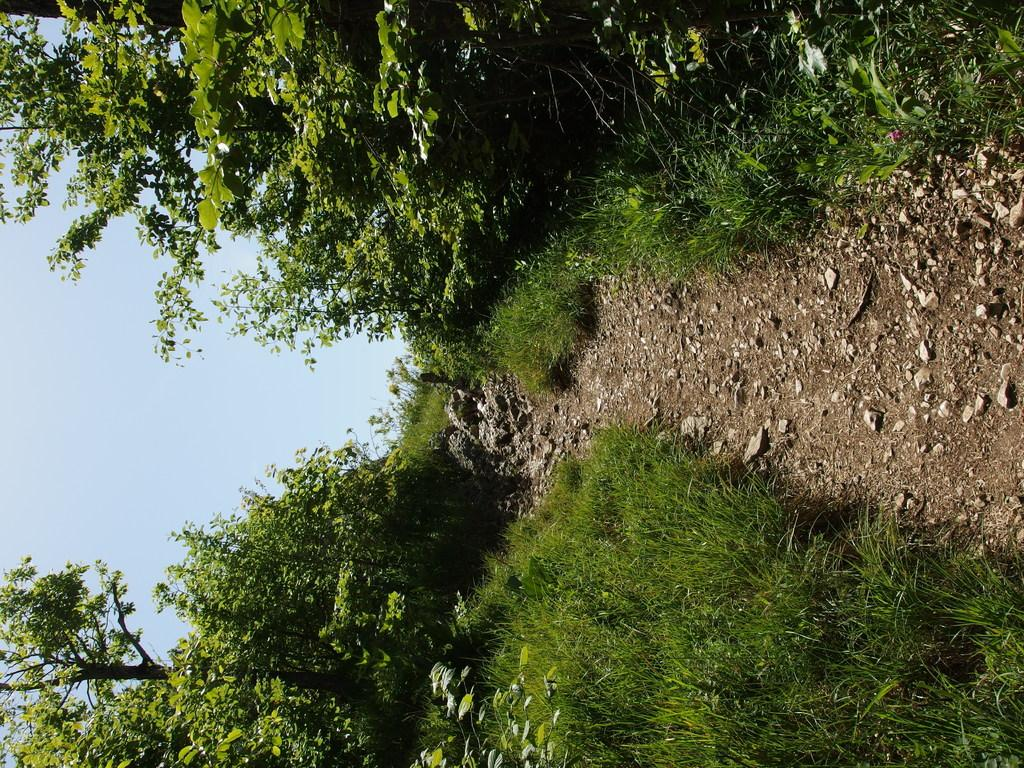What type of vegetation can be seen in the image? There are trees in the image. What part of the natural environment is visible in the image? The sky is visible on the left side of the image. What type of ice can be seen melting during the protest in the image? There is no protest or ice present in the image; it features trees and a visible sky. 